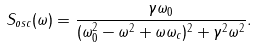<formula> <loc_0><loc_0><loc_500><loc_500>S _ { o s c } ( \omega ) = \frac { \gamma \omega _ { 0 } } { ( \omega _ { 0 } ^ { 2 } - \omega ^ { 2 } + \omega \omega _ { c } ) ^ { 2 } + \gamma ^ { 2 } \omega ^ { 2 } } .</formula> 